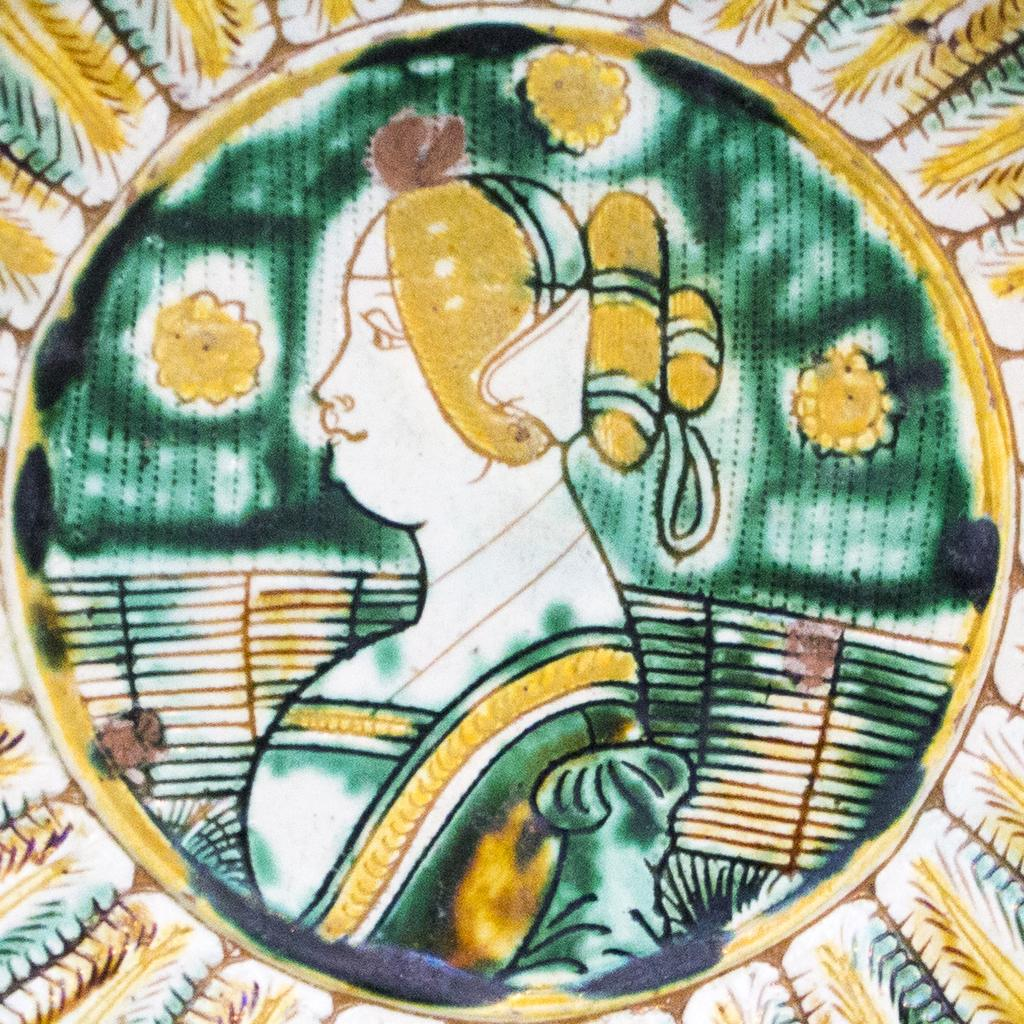What type of image is being described? The image is a drawing. What is the subject of the drawing? The drawing depicts a woman. How many houses are visible in the drawing? There are no houses depicted in the drawing; it features a woman. Is the woman part of a group in the drawing? The provided facts do not mention any other people or groups in the drawing, so it cannot be determined if the woman is part of a group. 